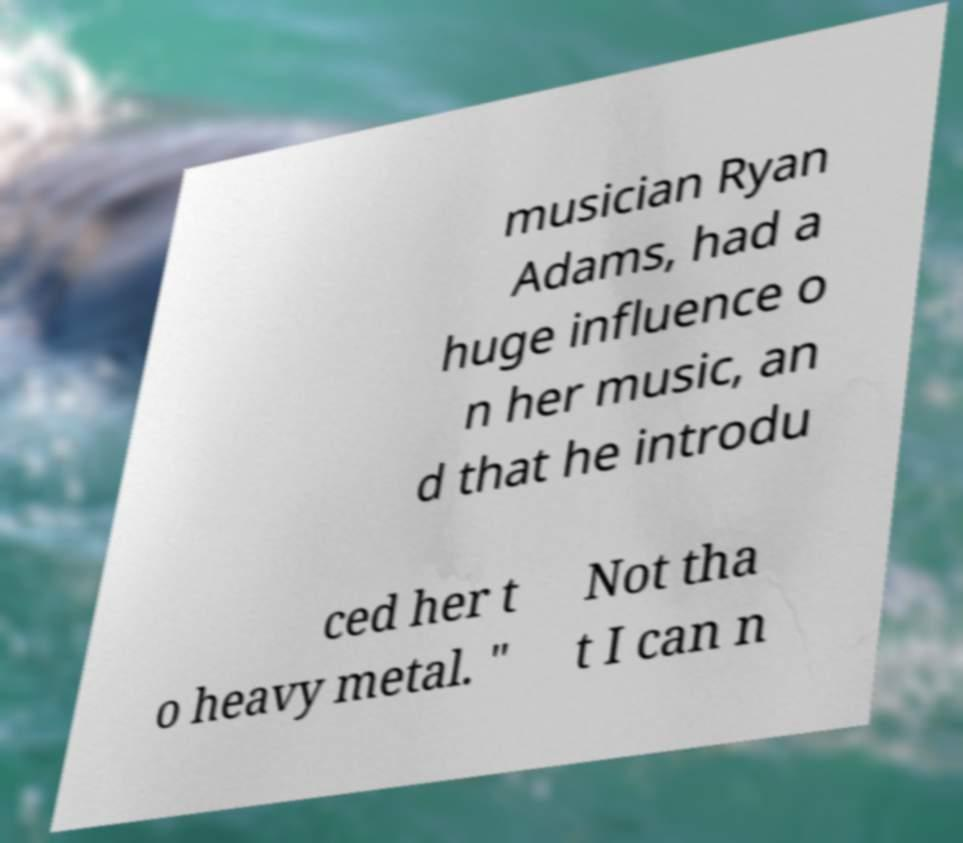Please identify and transcribe the text found in this image. musician Ryan Adams, had a huge influence o n her music, an d that he introdu ced her t o heavy metal. " Not tha t I can n 